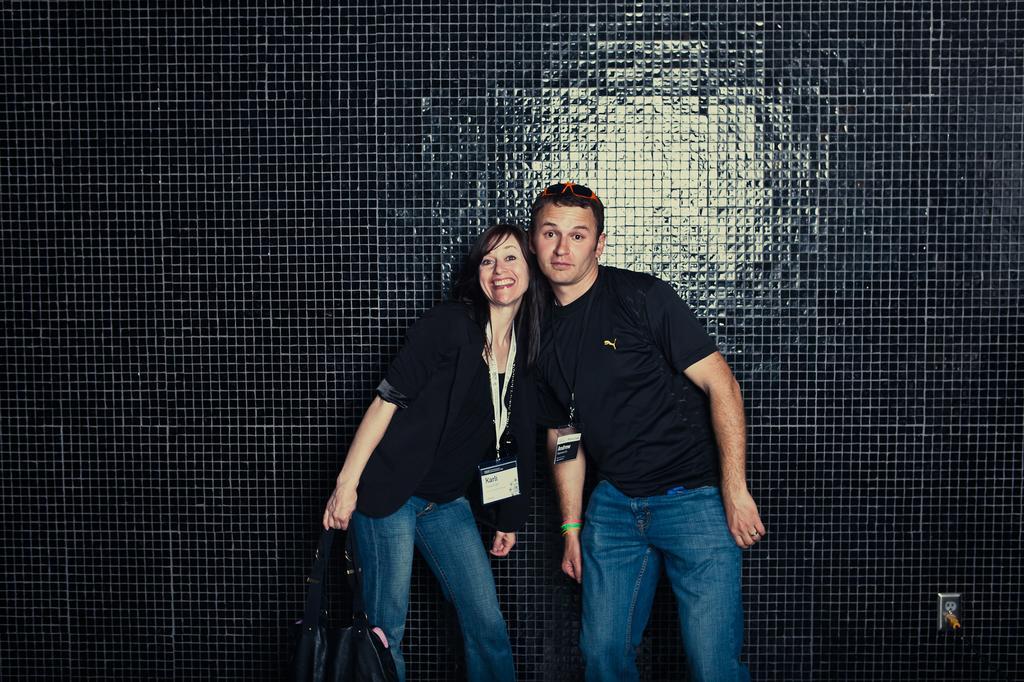Can you describe this image briefly? In this image I can see a woman and a man wearing black and blue colored dresses are standing. I can see the woman is holding a bag and the black colored wall in the background. 